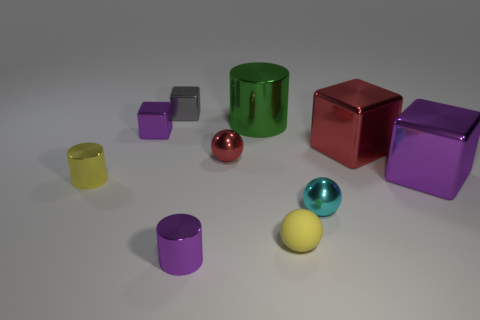Subtract all cubes. How many objects are left? 6 Add 10 large blue rubber cylinders. How many large blue rubber cylinders exist? 10 Subtract 1 red cubes. How many objects are left? 9 Subtract all large brown metallic objects. Subtract all tiny yellow cylinders. How many objects are left? 9 Add 2 small yellow shiny cylinders. How many small yellow shiny cylinders are left? 3 